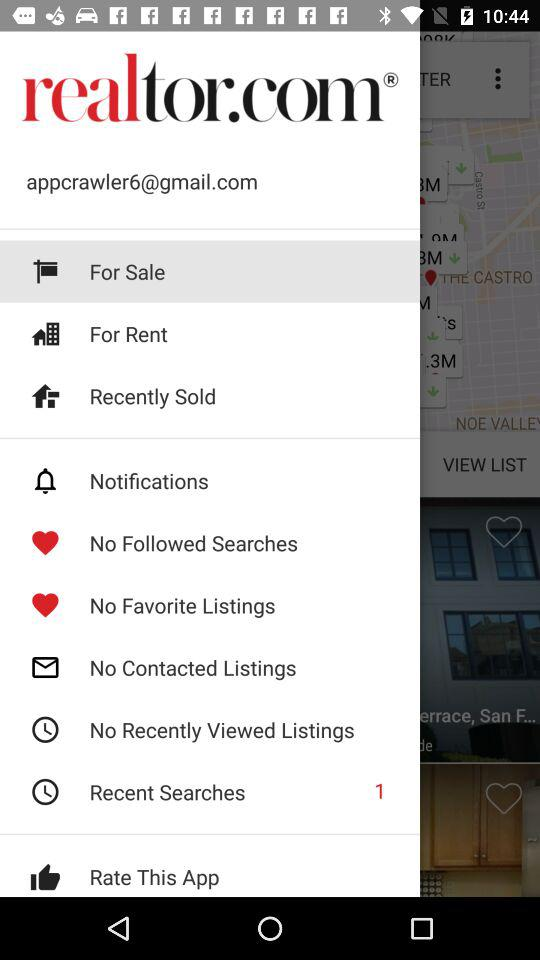How many notifications are pending in recent searches? There is 1 notification pending. 